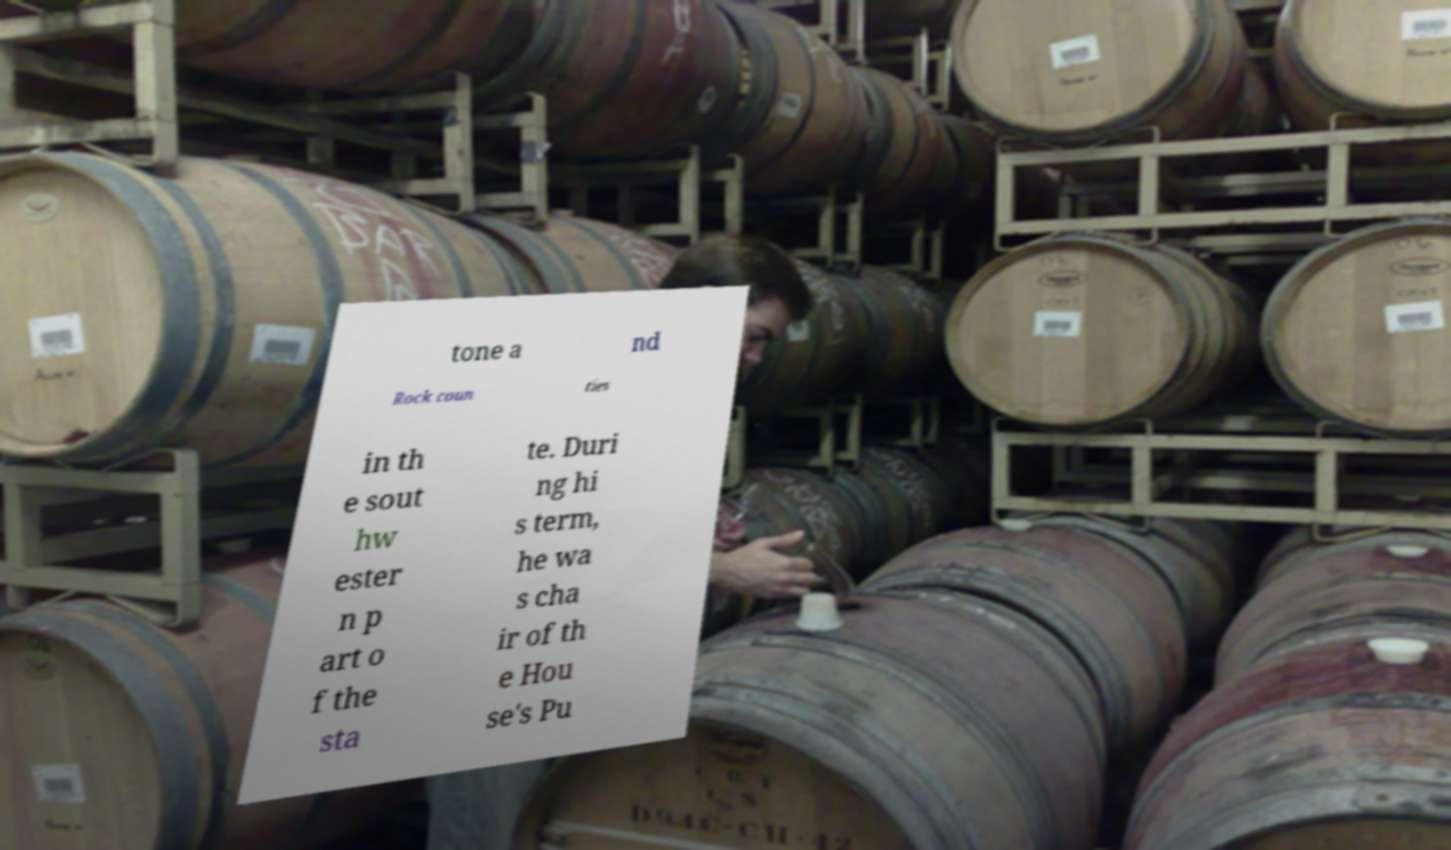For documentation purposes, I need the text within this image transcribed. Could you provide that? tone a nd Rock coun ties in th e sout hw ester n p art o f the sta te. Duri ng hi s term, he wa s cha ir of th e Hou se's Pu 